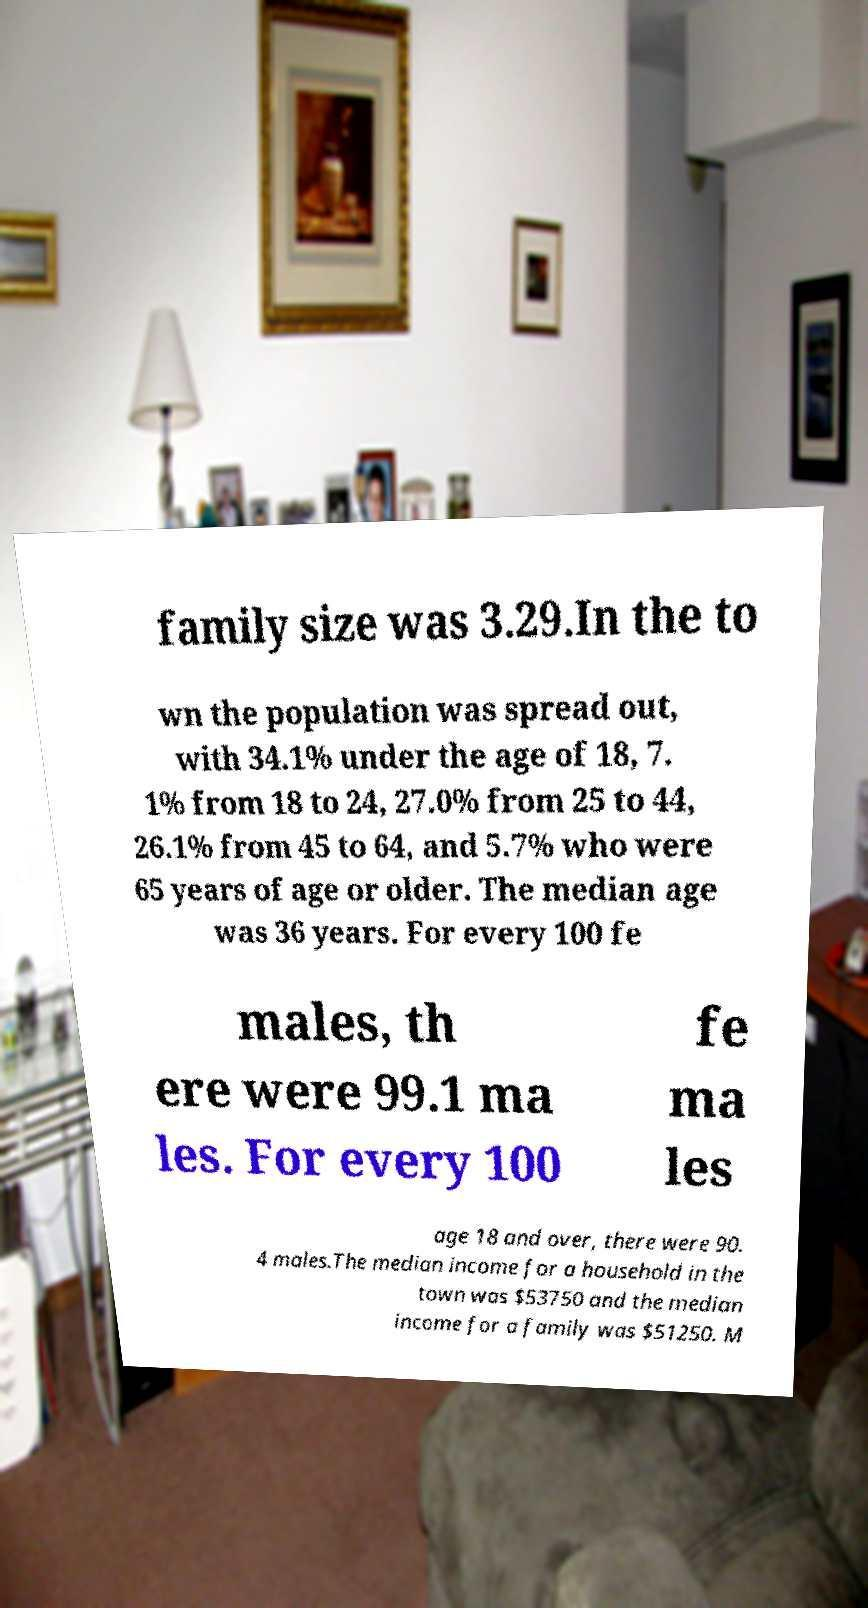Please identify and transcribe the text found in this image. family size was 3.29.In the to wn the population was spread out, with 34.1% under the age of 18, 7. 1% from 18 to 24, 27.0% from 25 to 44, 26.1% from 45 to 64, and 5.7% who were 65 years of age or older. The median age was 36 years. For every 100 fe males, th ere were 99.1 ma les. For every 100 fe ma les age 18 and over, there were 90. 4 males.The median income for a household in the town was $53750 and the median income for a family was $51250. M 